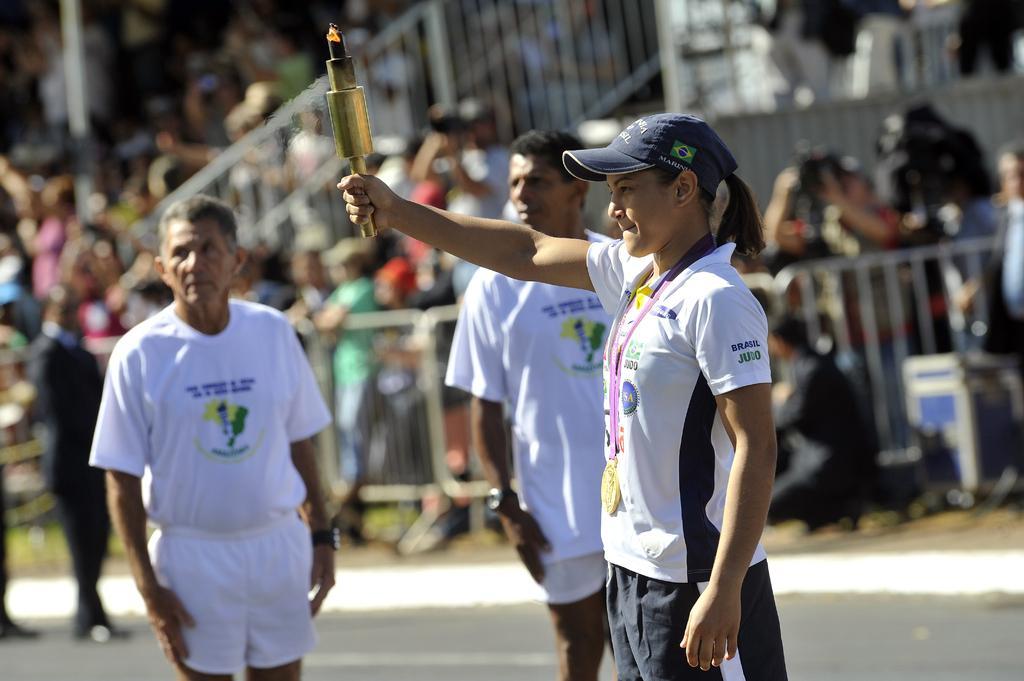In one or two sentences, can you explain what this image depicts? In this image we can see some people and one among them is holding an object which looks like a torch and in the background, the image is blurred. 